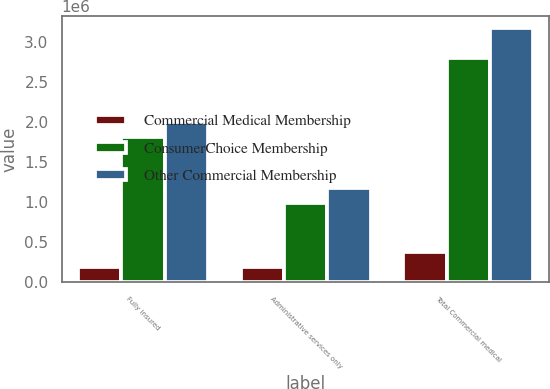Convert chart. <chart><loc_0><loc_0><loc_500><loc_500><stacked_bar_chart><ecel><fcel>Fully insured<fcel>Administrative services only<fcel>Total Commercial medical<nl><fcel>Commercial Medical Membership<fcel>184000<fcel>187100<fcel>371100<nl><fcel>ConsumerChoice Membership<fcel>1.8158e+06<fcel>983900<fcel>2.7997e+06<nl><fcel>Other Commercial Membership<fcel>1.9998e+06<fcel>1.171e+06<fcel>3.1708e+06<nl></chart> 